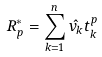<formula> <loc_0><loc_0><loc_500><loc_500>R ^ { * } _ { p } = \sum _ { k = 1 } ^ { n } \hat { v _ { k } } t ^ { p } _ { k }</formula> 